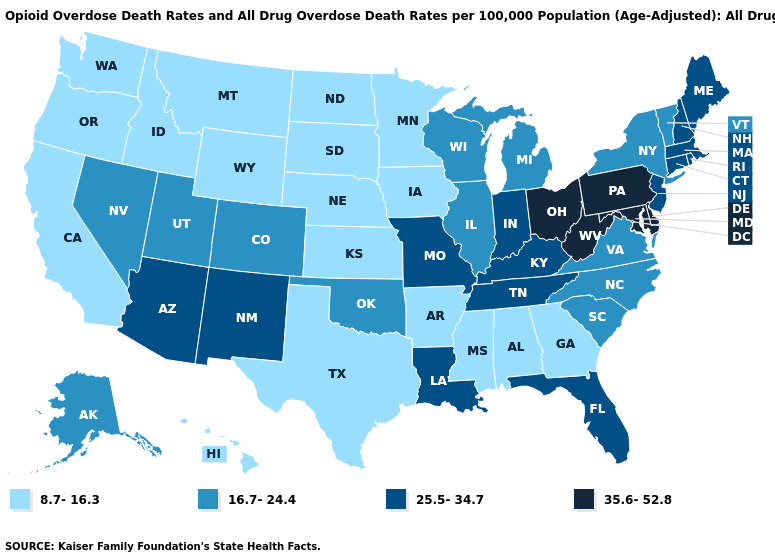What is the value of Alaska?
Short answer required. 16.7-24.4. What is the value of Connecticut?
Be succinct. 25.5-34.7. Does Massachusetts have the highest value in the Northeast?
Keep it brief. No. Does Hawaii have the lowest value in the USA?
Keep it brief. Yes. Does the map have missing data?
Keep it brief. No. Name the states that have a value in the range 8.7-16.3?
Quick response, please. Alabama, Arkansas, California, Georgia, Hawaii, Idaho, Iowa, Kansas, Minnesota, Mississippi, Montana, Nebraska, North Dakota, Oregon, South Dakota, Texas, Washington, Wyoming. Name the states that have a value in the range 8.7-16.3?
Write a very short answer. Alabama, Arkansas, California, Georgia, Hawaii, Idaho, Iowa, Kansas, Minnesota, Mississippi, Montana, Nebraska, North Dakota, Oregon, South Dakota, Texas, Washington, Wyoming. Does Indiana have a lower value than California?
Answer briefly. No. Does Delaware have the highest value in the USA?
Answer briefly. Yes. What is the highest value in the MidWest ?
Concise answer only. 35.6-52.8. Among the states that border New Hampshire , which have the highest value?
Short answer required. Maine, Massachusetts. What is the value of New Mexico?
Give a very brief answer. 25.5-34.7. Name the states that have a value in the range 35.6-52.8?
Write a very short answer. Delaware, Maryland, Ohio, Pennsylvania, West Virginia. What is the value of Vermont?
Short answer required. 16.7-24.4. 